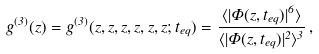<formula> <loc_0><loc_0><loc_500><loc_500>g ^ { ( 3 ) } ( z ) = g ^ { ( 3 ) } ( z , z , z , z , z , z ; t _ { e q } ) = \frac { \langle | \Phi ( z , t _ { e q } ) | ^ { 6 } \rangle } { \langle | \Phi ( z , t _ { e q } ) | ^ { 2 } \rangle ^ { 3 } } \, ,</formula> 